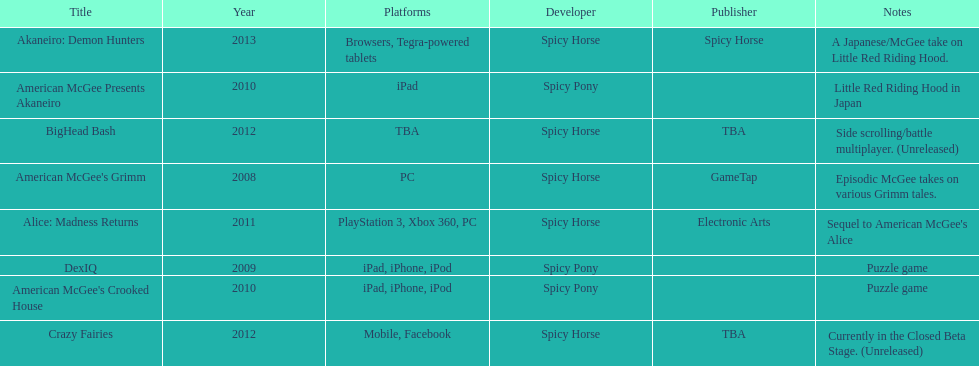What platform was used for the last title on this chart? Browsers, Tegra-powered tablets. 